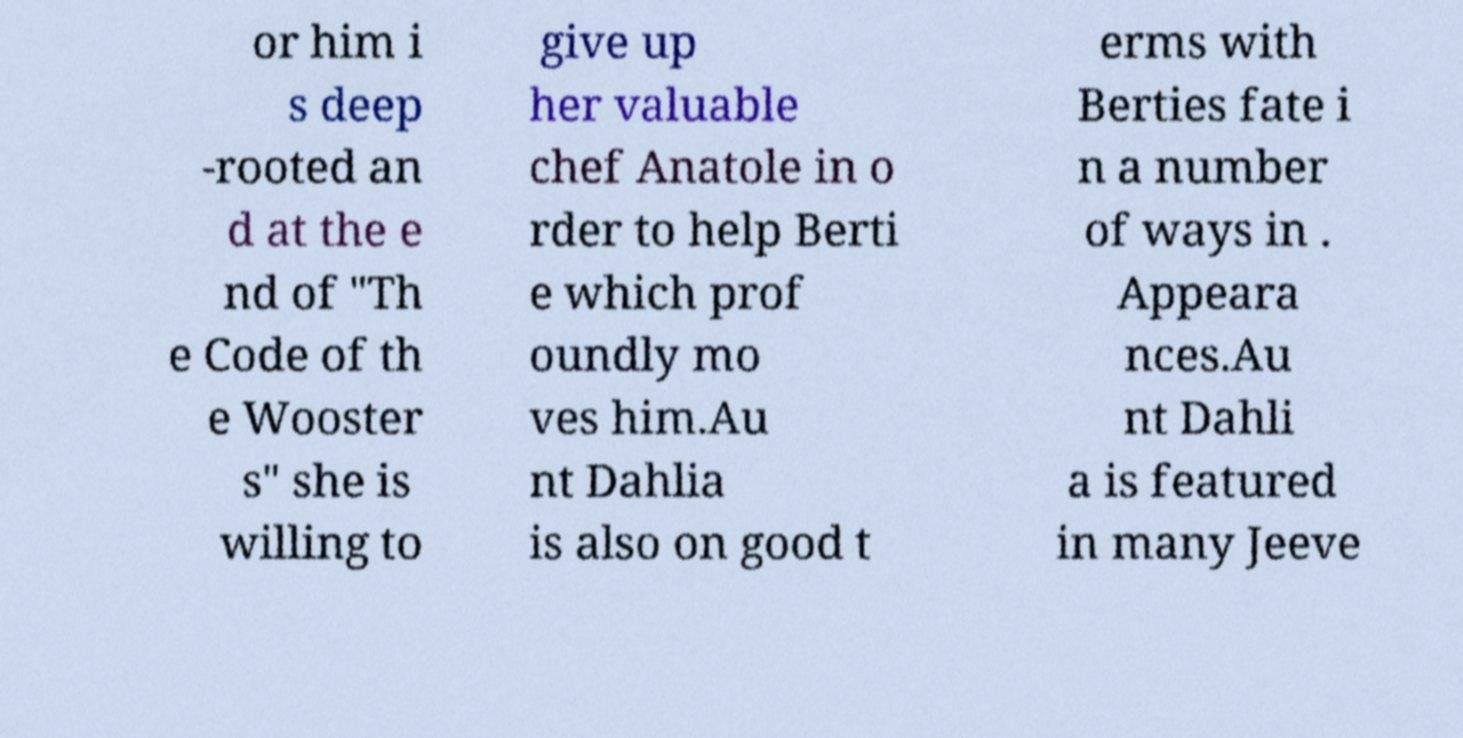What messages or text are displayed in this image? I need them in a readable, typed format. or him i s deep -rooted an d at the e nd of "Th e Code of th e Wooster s" she is willing to give up her valuable chef Anatole in o rder to help Berti e which prof oundly mo ves him.Au nt Dahlia is also on good t erms with Berties fate i n a number of ways in . Appeara nces.Au nt Dahli a is featured in many Jeeve 